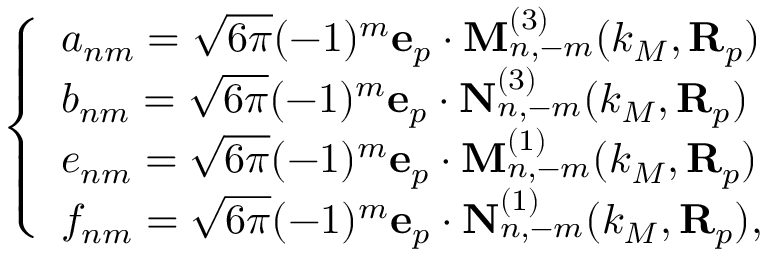Convert formula to latex. <formula><loc_0><loc_0><loc_500><loc_500>\left \{ \begin{array} { l l } { a _ { n m } = \sqrt { 6 \pi } ( - 1 ) ^ { m } e _ { p } \cdot M _ { n , - m } ^ { ( 3 ) } ( k _ { M } , R _ { p } ) } \\ { b _ { n m } = \sqrt { 6 \pi } ( - 1 ) ^ { m } e _ { p } \cdot N _ { n , - m } ^ { ( 3 ) } ( k _ { M } , R _ { p } ) } \\ { e _ { n m } = \sqrt { 6 \pi } ( - 1 ) ^ { m } e _ { p } \cdot M _ { n , - m } ^ { ( 1 ) } ( k _ { M } , R _ { p } ) } \\ { f _ { n m } = \sqrt { 6 \pi } ( - 1 ) ^ { m } e _ { p } \cdot N _ { n , - m } ^ { ( 1 ) } ( k _ { M } , R _ { p } ) , } \end{array}</formula> 